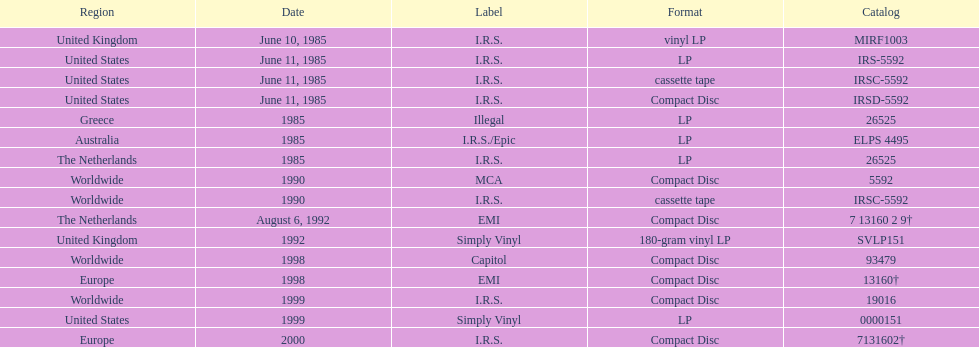Write the full table. {'header': ['Region', 'Date', 'Label', 'Format', 'Catalog'], 'rows': [['United Kingdom', 'June 10, 1985', 'I.R.S.', 'vinyl LP', 'MIRF1003'], ['United States', 'June 11, 1985', 'I.R.S.', 'LP', 'IRS-5592'], ['United States', 'June 11, 1985', 'I.R.S.', 'cassette tape', 'IRSC-5592'], ['United States', 'June 11, 1985', 'I.R.S.', 'Compact Disc', 'IRSD-5592'], ['Greece', '1985', 'Illegal', 'LP', '26525'], ['Australia', '1985', 'I.R.S./Epic', 'LP', 'ELPS 4495'], ['The Netherlands', '1985', 'I.R.S.', 'LP', '26525'], ['Worldwide', '1990', 'MCA', 'Compact Disc', '5592'], ['Worldwide', '1990', 'I.R.S.', 'cassette tape', 'IRSC-5592'], ['The Netherlands', 'August 6, 1992', 'EMI', 'Compact Disc', '7 13160 2 9†'], ['United Kingdom', '1992', 'Simply Vinyl', '180-gram vinyl LP', 'SVLP151'], ['Worldwide', '1998', 'Capitol', 'Compact Disc', '93479'], ['Europe', '1998', 'EMI', 'Compact Disc', '13160†'], ['Worldwide', '1999', 'I.R.S.', 'Compact Disc', '19016'], ['United States', '1999', 'Simply Vinyl', 'LP', '0000151'], ['Europe', '2000', 'I.R.S.', 'Compact Disc', '7131602†']]} Which year had the most releases? 1985. 